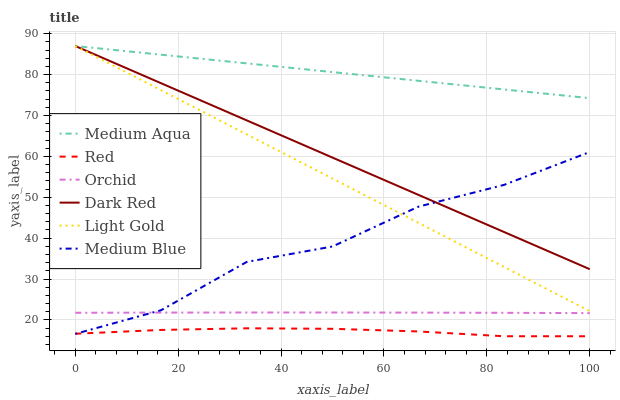Does Red have the minimum area under the curve?
Answer yes or no. Yes. Does Medium Aqua have the maximum area under the curve?
Answer yes or no. Yes. Does Medium Blue have the minimum area under the curve?
Answer yes or no. No. Does Medium Blue have the maximum area under the curve?
Answer yes or no. No. Is Dark Red the smoothest?
Answer yes or no. Yes. Is Medium Blue the roughest?
Answer yes or no. Yes. Is Medium Aqua the smoothest?
Answer yes or no. No. Is Medium Aqua the roughest?
Answer yes or no. No. Does Red have the lowest value?
Answer yes or no. Yes. Does Medium Blue have the lowest value?
Answer yes or no. No. Does Light Gold have the highest value?
Answer yes or no. Yes. Does Medium Blue have the highest value?
Answer yes or no. No. Is Medium Blue less than Medium Aqua?
Answer yes or no. Yes. Is Dark Red greater than Red?
Answer yes or no. Yes. Does Dark Red intersect Medium Aqua?
Answer yes or no. Yes. Is Dark Red less than Medium Aqua?
Answer yes or no. No. Is Dark Red greater than Medium Aqua?
Answer yes or no. No. Does Medium Blue intersect Medium Aqua?
Answer yes or no. No. 